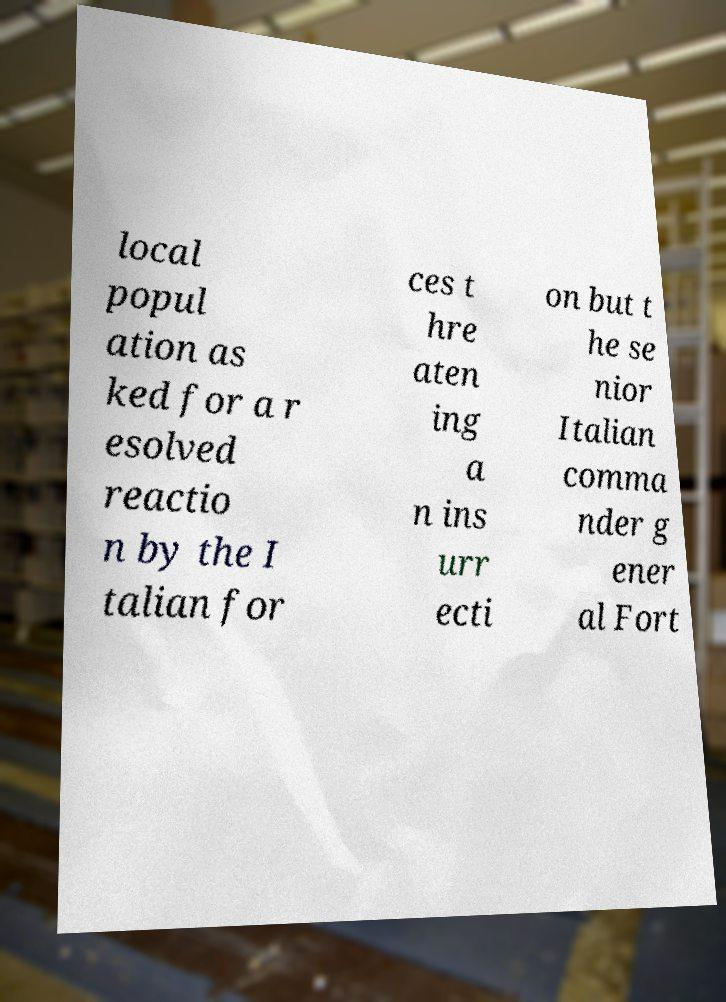I need the written content from this picture converted into text. Can you do that? local popul ation as ked for a r esolved reactio n by the I talian for ces t hre aten ing a n ins urr ecti on but t he se nior Italian comma nder g ener al Fort 